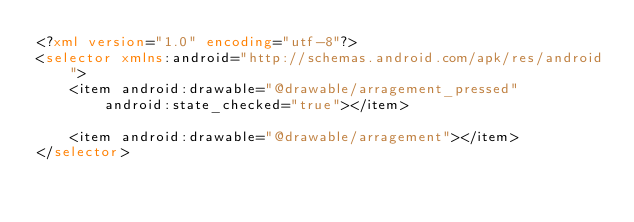<code> <loc_0><loc_0><loc_500><loc_500><_XML_><?xml version="1.0" encoding="utf-8"?>
<selector xmlns:android="http://schemas.android.com/apk/res/android">
    <item android:drawable="@drawable/arragement_pressed"
        android:state_checked="true"></item>

    <item android:drawable="@drawable/arragement"></item>
</selector></code> 